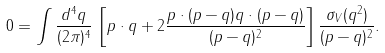Convert formula to latex. <formula><loc_0><loc_0><loc_500><loc_500>0 = \int \frac { d ^ { 4 } q } { ( 2 \pi ) ^ { 4 } } \, \left [ p \cdot q + 2 \frac { p \cdot ( p - q ) q \cdot ( p - q ) } { ( p - q ) ^ { 2 } } \right ] \frac { \sigma _ { V } ( q ^ { 2 } ) } { ( p - q ) ^ { 2 } } .</formula> 